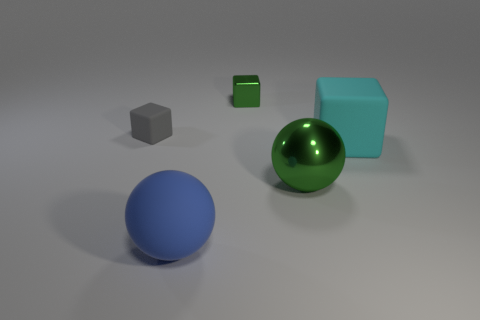Add 2 big rubber cubes. How many objects exist? 7 Subtract all big matte cubes. How many cubes are left? 2 Subtract all spheres. How many objects are left? 3 Subtract all large blue metal spheres. Subtract all tiny cubes. How many objects are left? 3 Add 3 big cyan things. How many big cyan things are left? 4 Add 2 tiny green things. How many tiny green things exist? 3 Subtract all gray blocks. How many blocks are left? 2 Subtract 1 blue balls. How many objects are left? 4 Subtract 1 blocks. How many blocks are left? 2 Subtract all gray spheres. Subtract all blue blocks. How many spheres are left? 2 